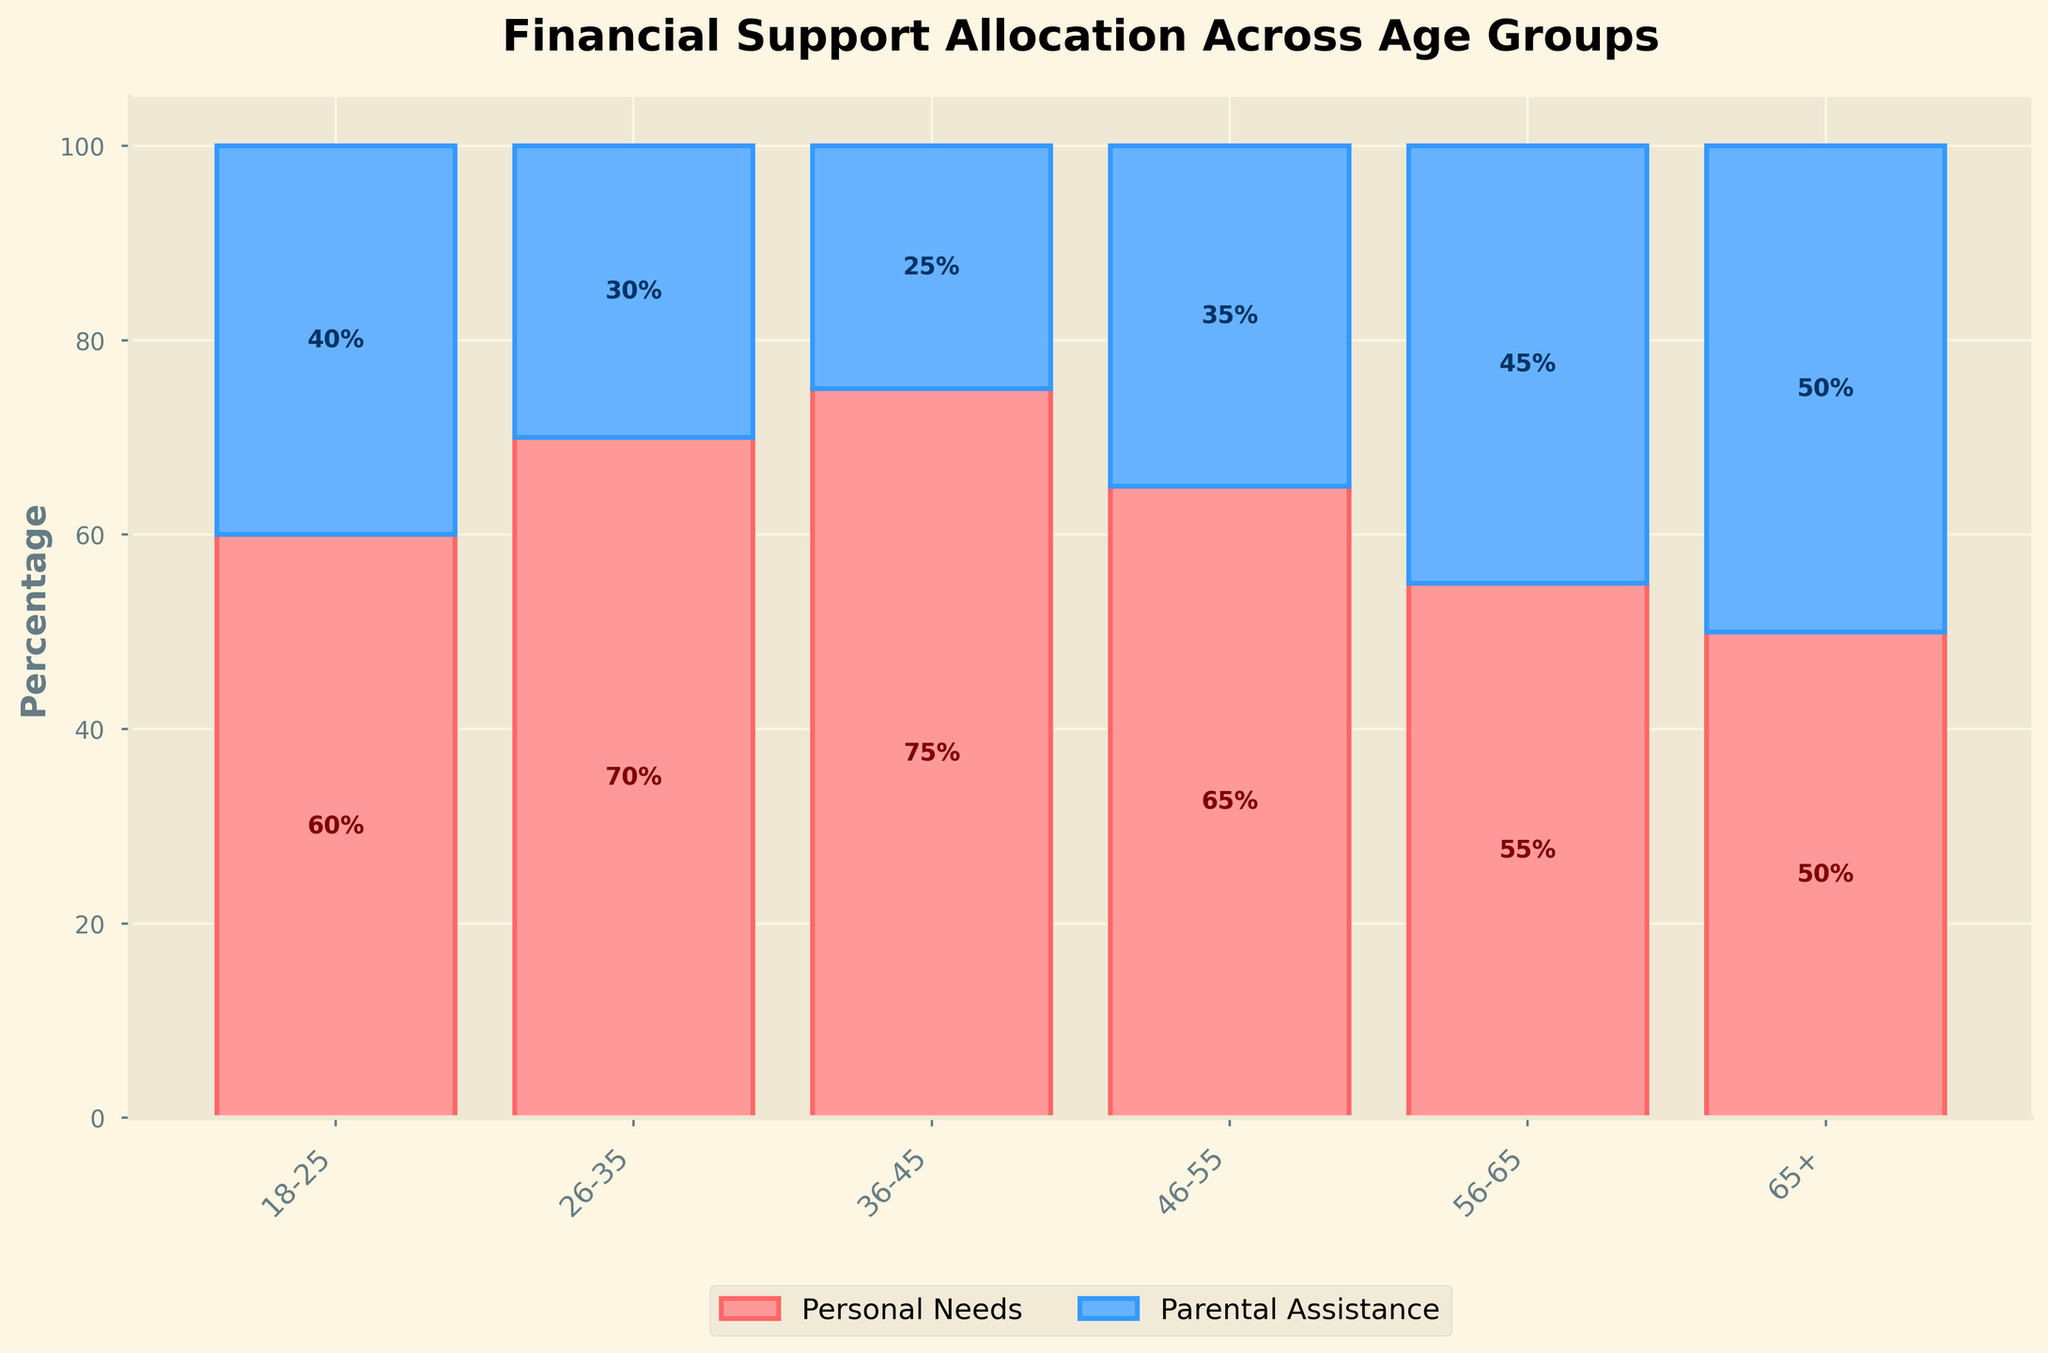What is the title of the figure? The title is located at the top of the figure. It reads "Financial Support Allocation Across Age Groups".
Answer: Financial Support Allocation Across Age Groups Which age group allocates the highest percentage to personal needs? By examining the heights of the bars labeled "Personal Needs", the age group 36-45 has the highest percentage allocation to personal needs with a value of 75%.
Answer: 36-45 What are the exact percentages of personal needs and parental assistance for the age group 26-35? The bar segments corresponding to the age group 26-35 show personal needs at 70% and parental assistance at 30%.
Answer: 70% and 30% Which age group has an equal distribution between personal needs and parental assistance? The bar for the age group 65+ shows a 50% allocation to both personal needs and parental assistance, indicating equal distribution.
Answer: 65+ How does the allocation of financial support for personal needs change from the age group 18-25 to 36-45? The bar heights for personal needs from 18-25 (60%) to 36-45 (75%) show an increase. First, it transitions to 70% (26-35) and then to 75% (36-45).
Answer: It increases Compare the personal needs allocation percentages between the age groups 18-25 and 56-65. The personal needs percentage for the age group 18-25 is 60%, whereas it is 55% for the age group 56-65, indicating a 5% decrease.
Answer: 18-25 has a higher percentage What is the difference in percentage allocation for parental assistance between the age groups 46-55 and 65+? The parental assistance percentage for the age group 46-55 is 35%, while it is 50% for the age group 65+. The difference is 50% - 35% = 15%.
Answer: 15% Which age group allocates the lowest percentage to parental assistance? By inspecting the bar segments labeled "Parental Assistance", the age group 36-45 allocates the lowest percentage at 25%.
Answer: 36-45 How does the overall trend of financial support allocation for personal needs change across different age groups? Observing the bars from left to right, personal needs allocation generally increases until the age group 36-45, peaks at 75%, and then decreases in the older age groups.
Answer: Increases and then decreases What is the total percentage allocated to both personal needs and parental assistance for the age group 46-55? The sum of the percentages for both personal needs and parental assistance for the age group 46-55 is 65% (personal needs) + 35% (parental assistance) = 100%.
Answer: 100% 